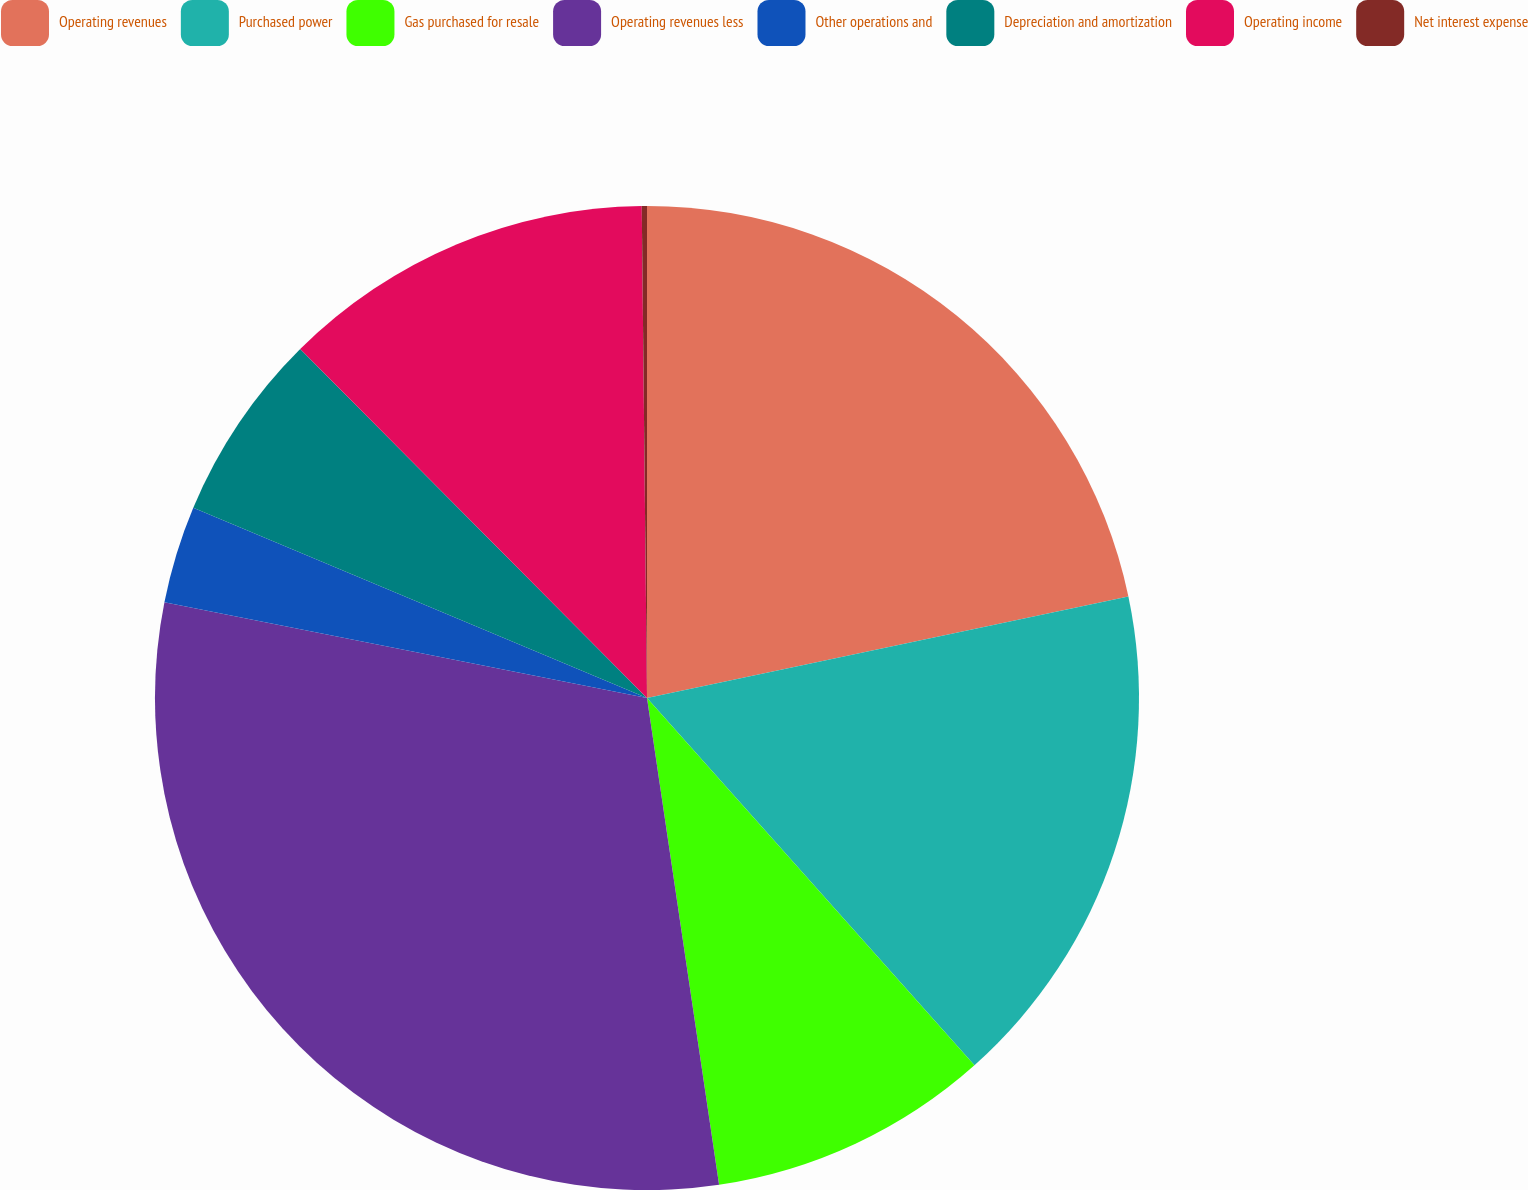Convert chart. <chart><loc_0><loc_0><loc_500><loc_500><pie_chart><fcel>Operating revenues<fcel>Purchased power<fcel>Gas purchased for resale<fcel>Operating revenues less<fcel>Other operations and<fcel>Depreciation and amortization<fcel>Operating income<fcel>Net interest expense<nl><fcel>21.69%<fcel>16.72%<fcel>9.25%<fcel>30.46%<fcel>3.2%<fcel>6.23%<fcel>12.28%<fcel>0.17%<nl></chart> 